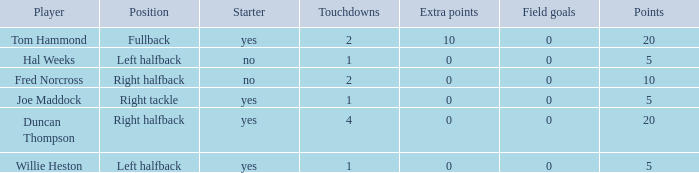What is the highest field goals when there were more than 1 touchdown and 0 extra points? 0.0. 